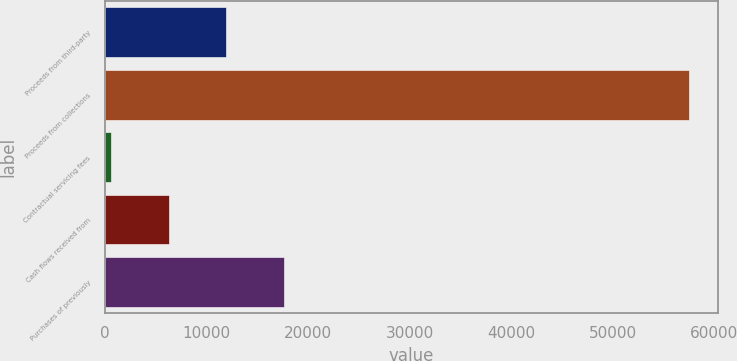Convert chart. <chart><loc_0><loc_0><loc_500><loc_500><bar_chart><fcel>Proceeds from third-party<fcel>Proceeds from collections<fcel>Contractual servicing fees<fcel>Cash flows received from<fcel>Purchases of previously<nl><fcel>11943.8<fcel>57495<fcel>556<fcel>6249.9<fcel>17637.7<nl></chart> 